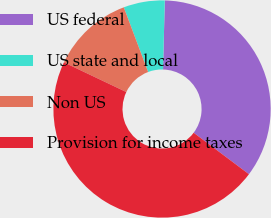Convert chart. <chart><loc_0><loc_0><loc_500><loc_500><pie_chart><fcel>US federal<fcel>US state and local<fcel>Non US<fcel>Provision for income taxes<nl><fcel>34.84%<fcel>6.13%<fcel>12.21%<fcel>46.82%<nl></chart> 